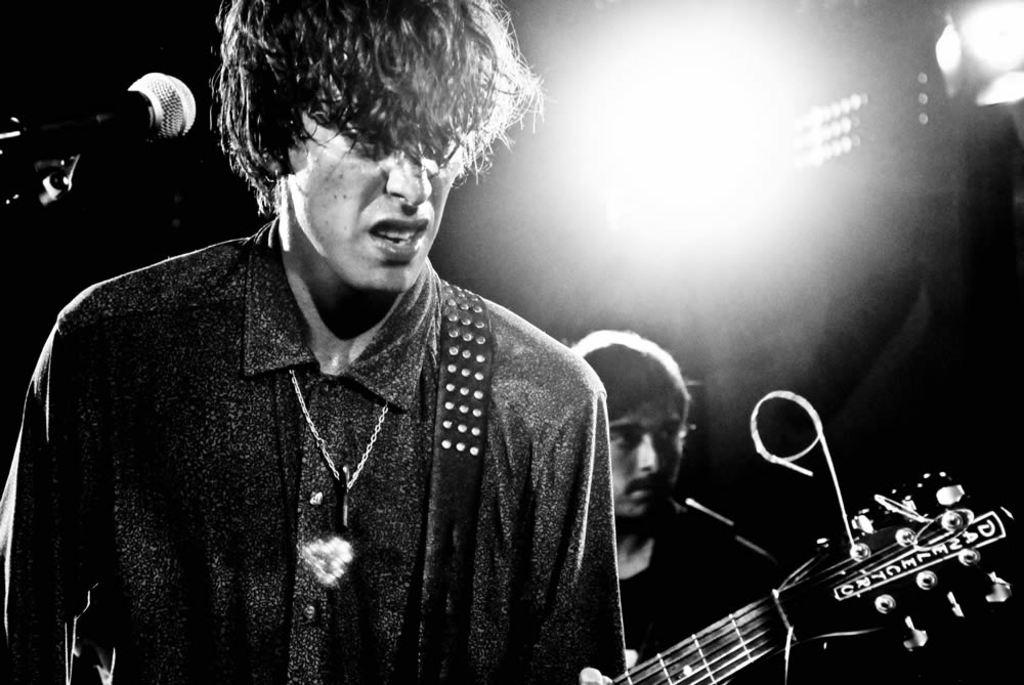How many people are in the image? There are two persons in the image. What is one of the persons holding? One of the persons is holding a guitar. What object is present in the image that is commonly used for amplifying sound? There is a microphone in the image. What type of insurance policy is the person holding the guitar discussing with the other person in the image? There is no indication in the image that the persons are discussing insurance policies. The focus is on the guitar and microphone, which suggest a musical context. 